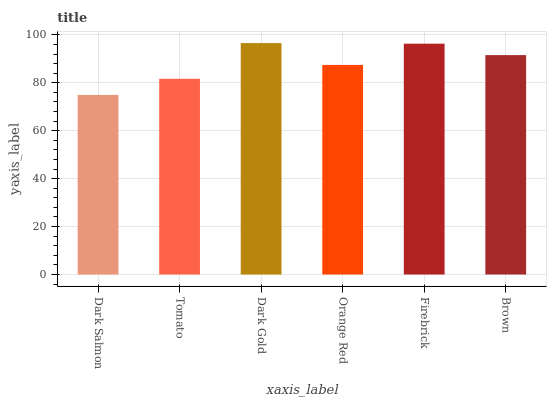Is Dark Salmon the minimum?
Answer yes or no. Yes. Is Dark Gold the maximum?
Answer yes or no. Yes. Is Tomato the minimum?
Answer yes or no. No. Is Tomato the maximum?
Answer yes or no. No. Is Tomato greater than Dark Salmon?
Answer yes or no. Yes. Is Dark Salmon less than Tomato?
Answer yes or no. Yes. Is Dark Salmon greater than Tomato?
Answer yes or no. No. Is Tomato less than Dark Salmon?
Answer yes or no. No. Is Brown the high median?
Answer yes or no. Yes. Is Orange Red the low median?
Answer yes or no. Yes. Is Firebrick the high median?
Answer yes or no. No. Is Tomato the low median?
Answer yes or no. No. 